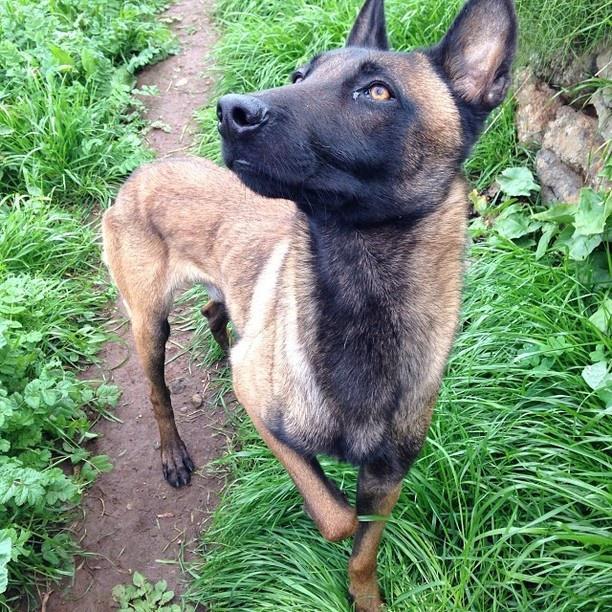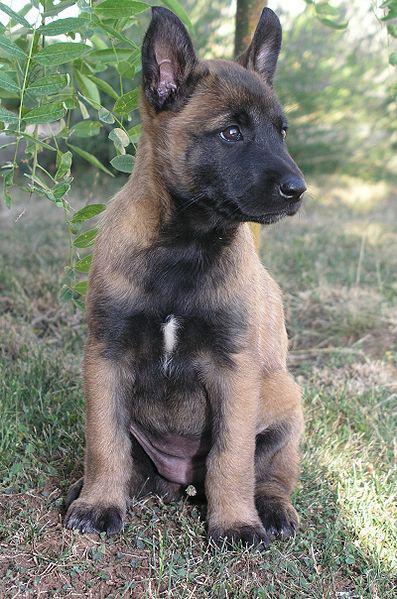The first image is the image on the left, the second image is the image on the right. Analyze the images presented: Is the assertion "The dogs are looking in the same direction" valid? Answer yes or no. No. The first image is the image on the left, the second image is the image on the right. Given the left and right images, does the statement "There are exactly two German Shepherd dogs and either they both have collars around their neck or neither do." hold true? Answer yes or no. Yes. 